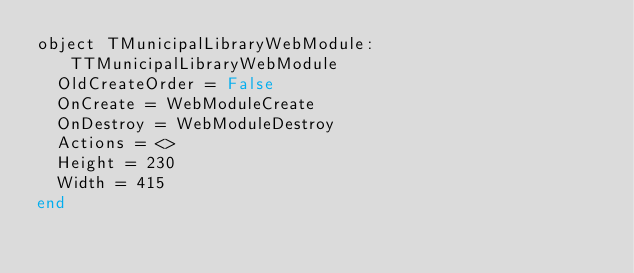<code> <loc_0><loc_0><loc_500><loc_500><_Pascal_>object TMunicipalLibraryWebModule: TTMunicipalLibraryWebModule
  OldCreateOrder = False
  OnCreate = WebModuleCreate
  OnDestroy = WebModuleDestroy
  Actions = <>
  Height = 230
  Width = 415
end
</code> 